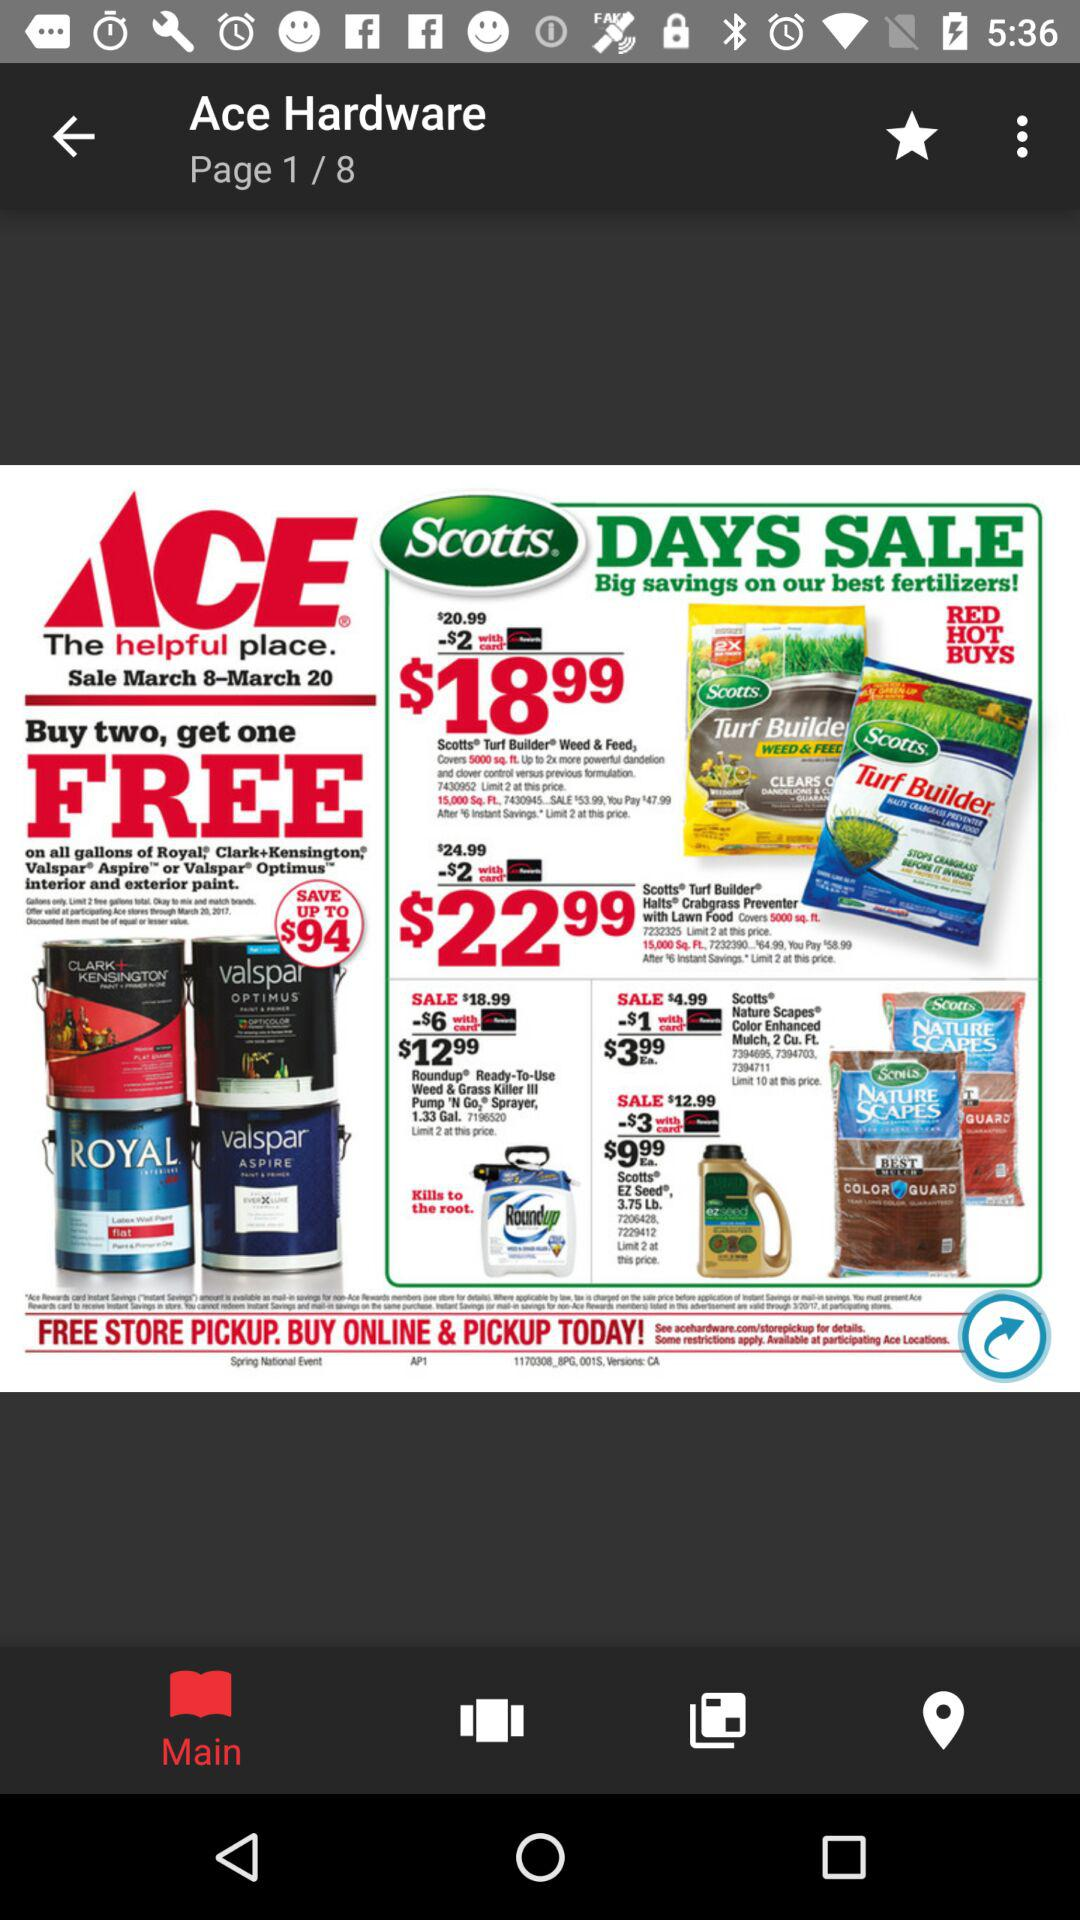Which tab is selected? The selected tab is "Main". 